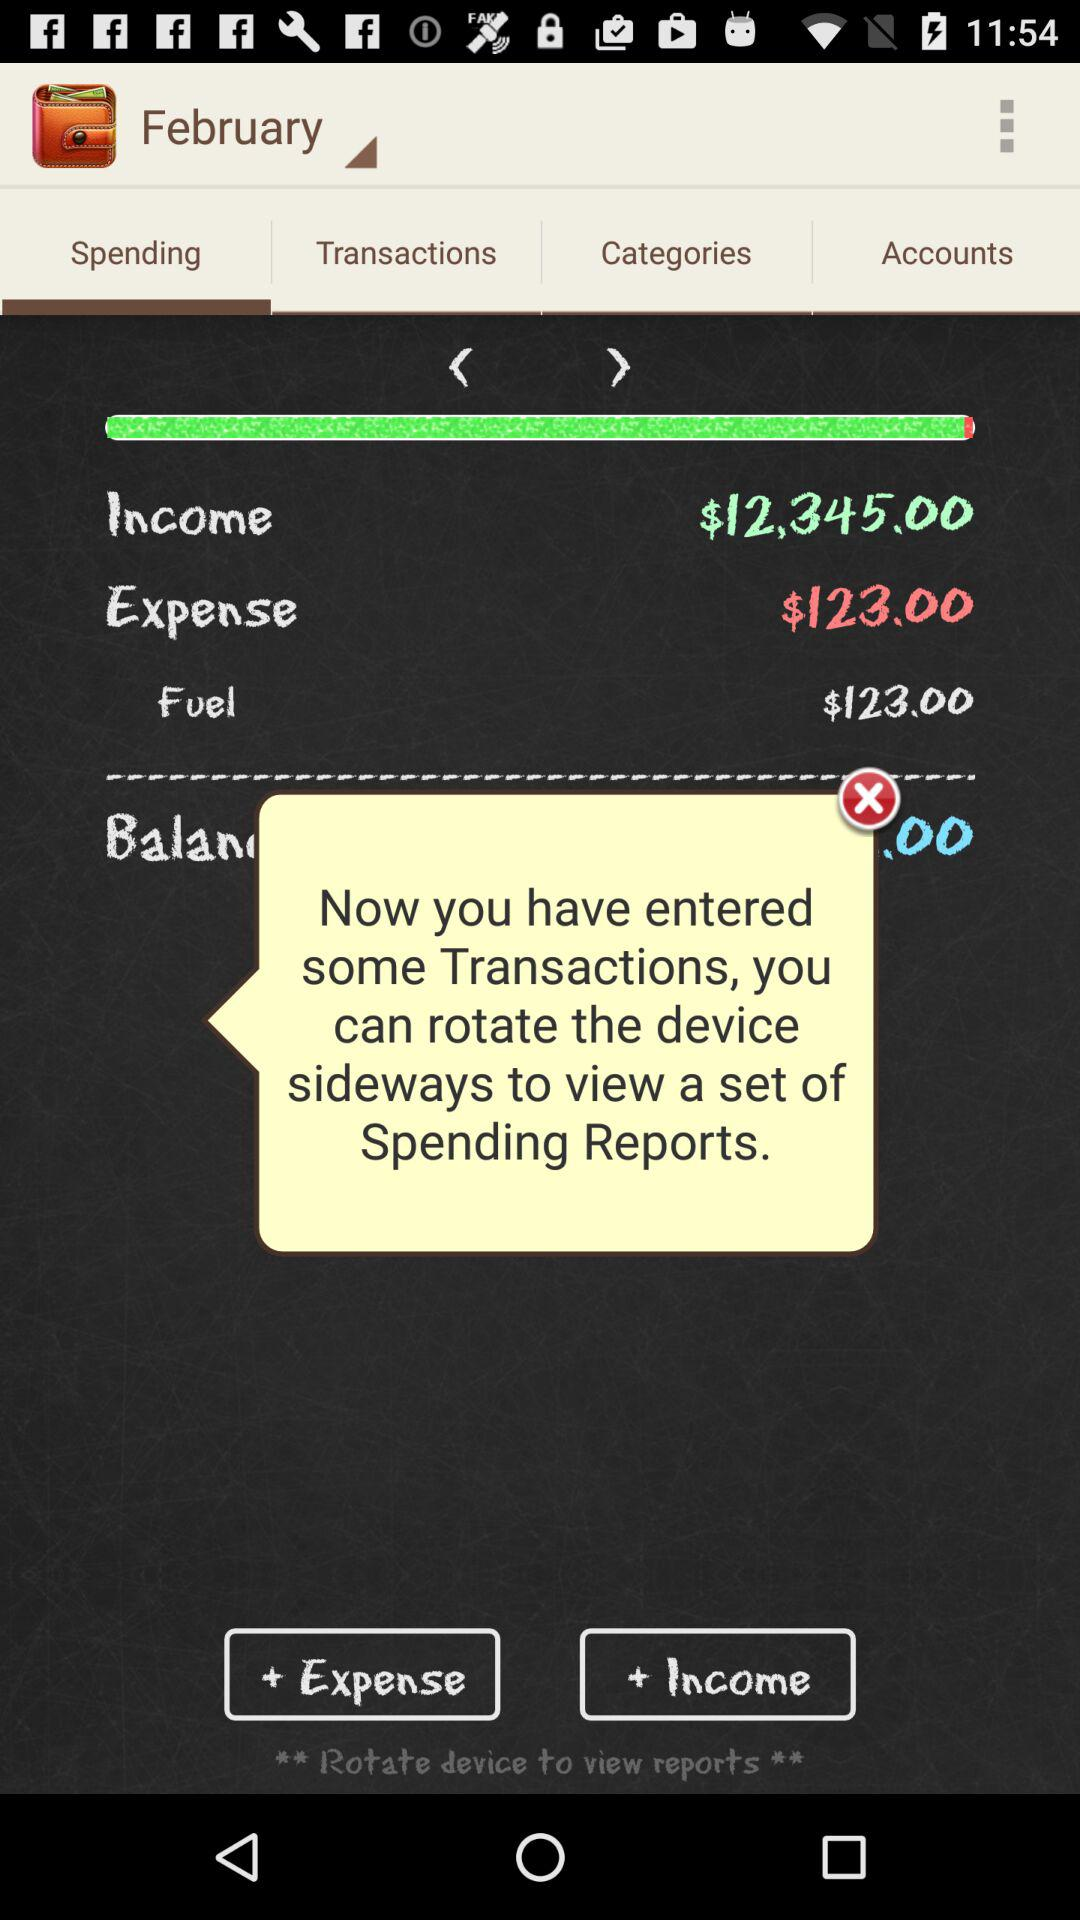What is the total income?
Answer the question using a single word or phrase. $12,345.00 